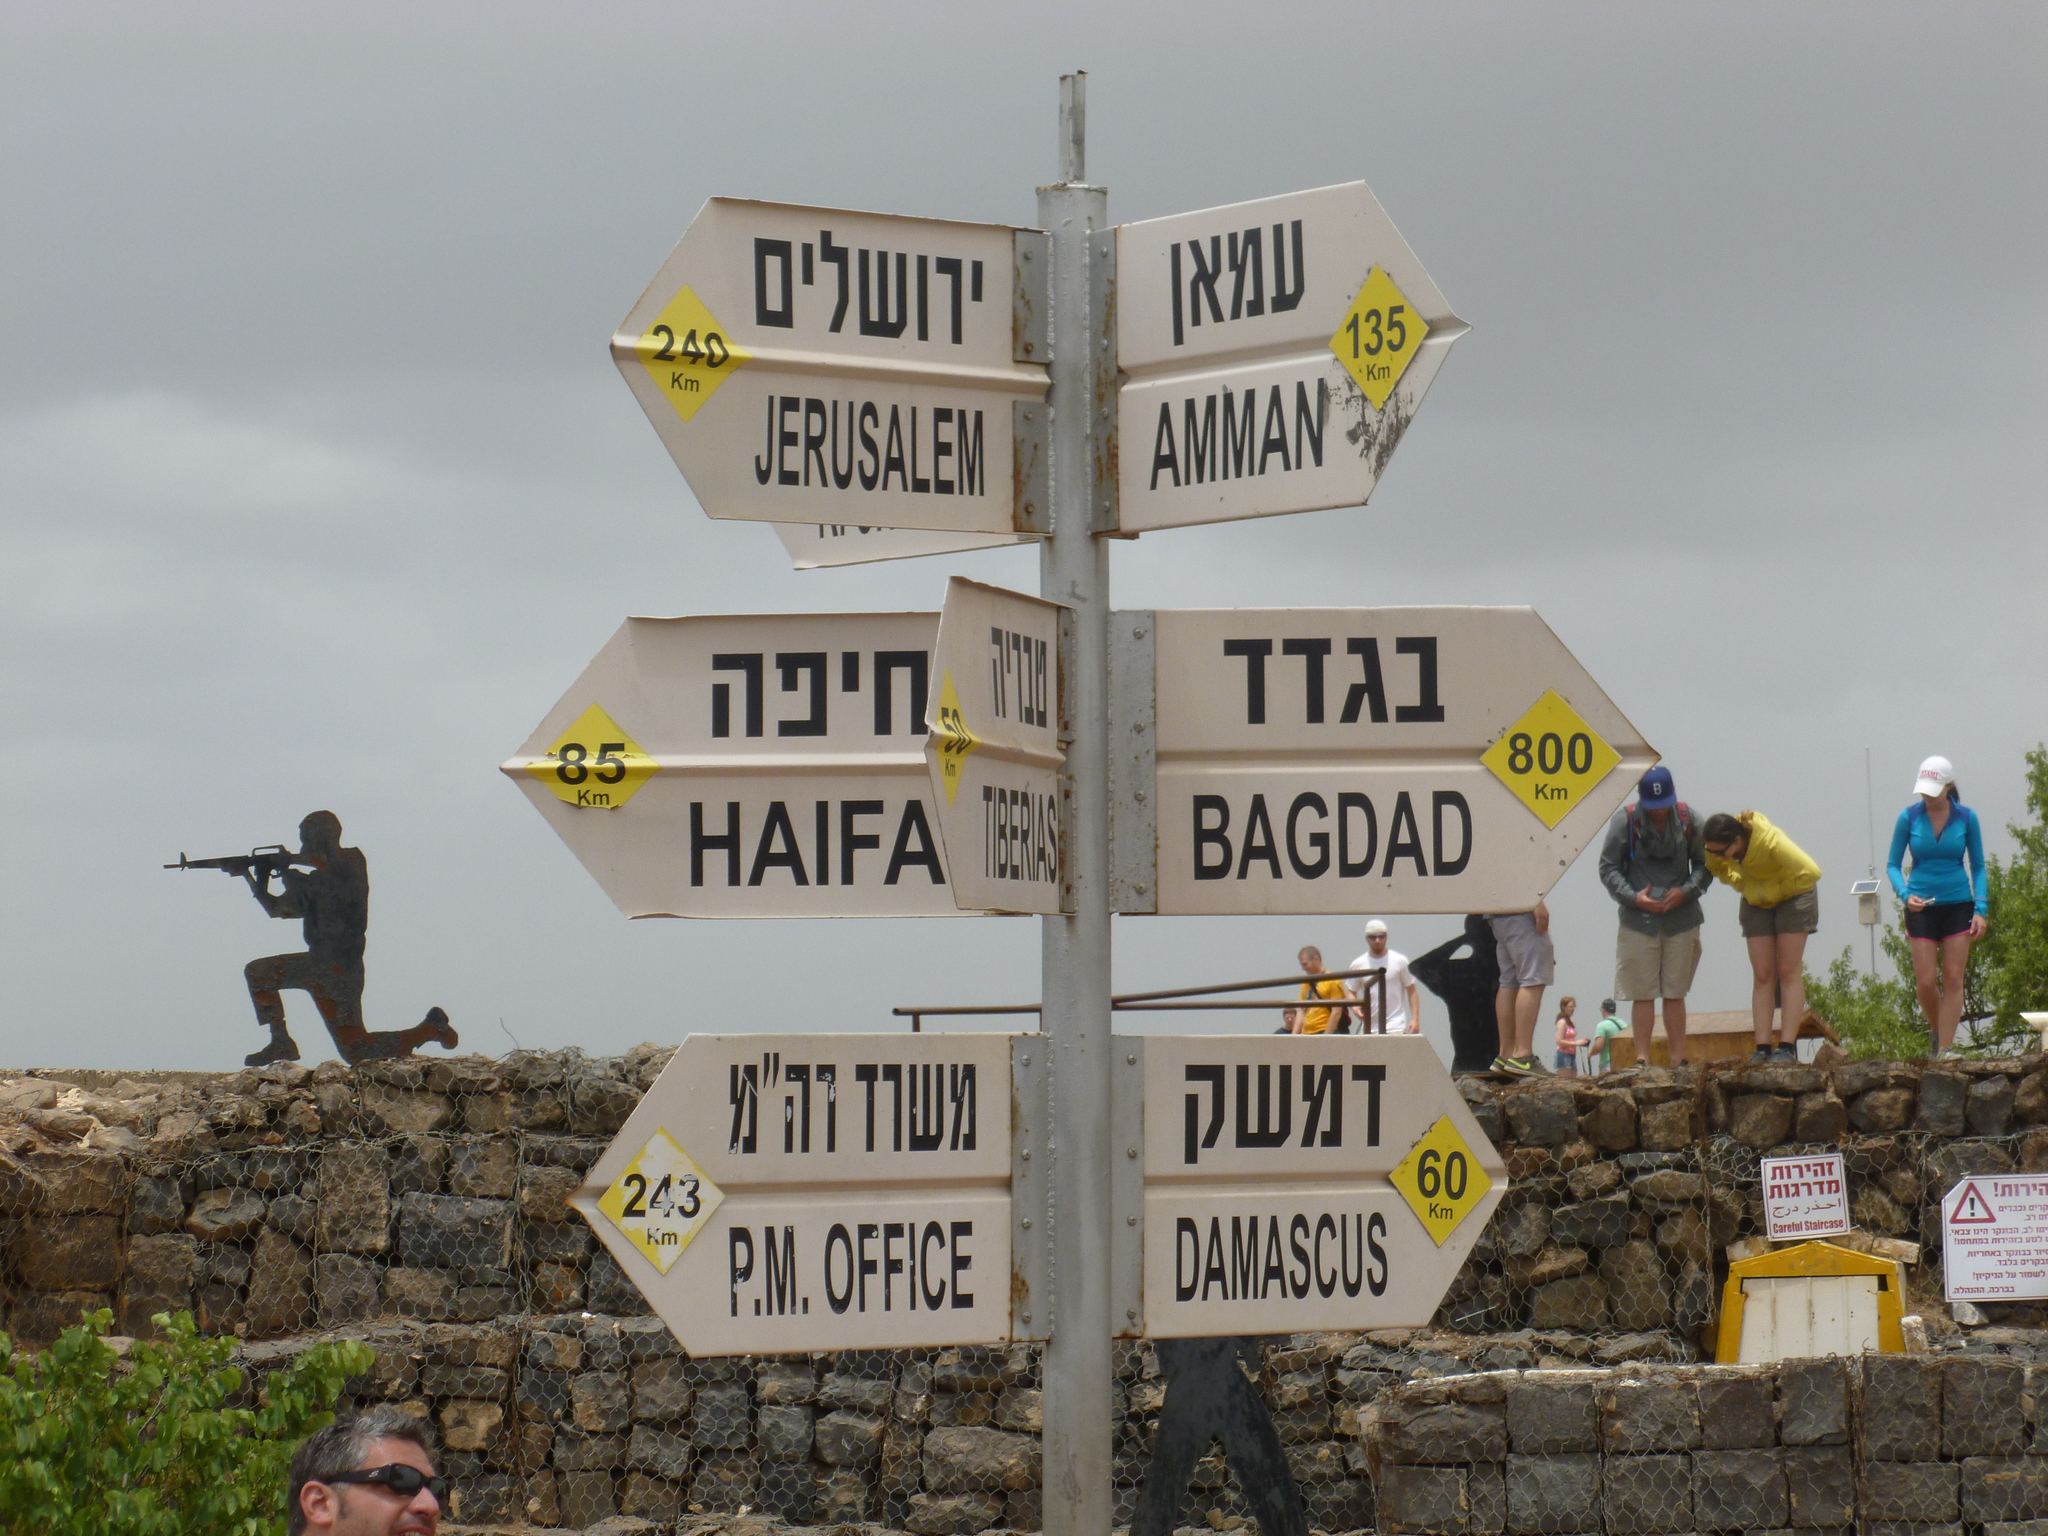<image>
Describe the image concisely. A sign indicates that Bagdad is to the right and Jerusalem is to the left. 